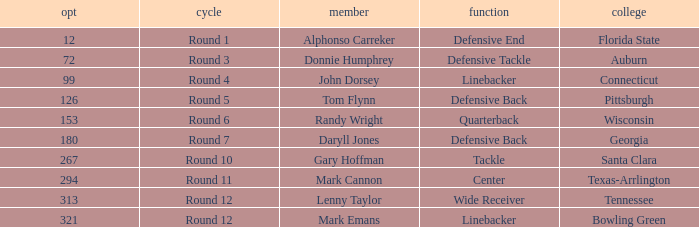What Player is a Wide Receiver? Lenny Taylor. 